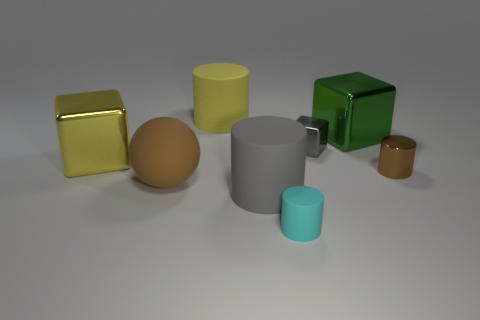Subtract all small metallic blocks. How many blocks are left? 2 Add 1 big green metallic cubes. How many objects exist? 9 Subtract all yellow cubes. How many cubes are left? 2 Subtract 2 cylinders. How many cylinders are left? 2 Subtract 0 green balls. How many objects are left? 8 Subtract all balls. How many objects are left? 7 Subtract all green cylinders. Subtract all purple balls. How many cylinders are left? 4 Subtract all purple cubes. How many purple cylinders are left? 0 Subtract all tiny blocks. Subtract all small rubber cylinders. How many objects are left? 6 Add 5 metallic cylinders. How many metallic cylinders are left? 6 